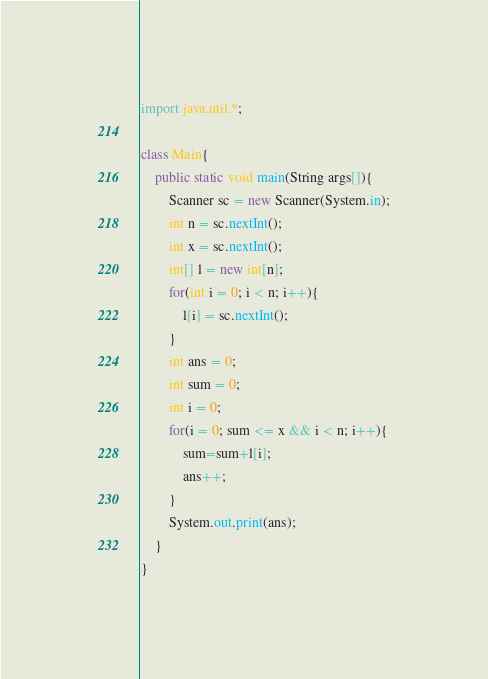Convert code to text. <code><loc_0><loc_0><loc_500><loc_500><_Java_>import java.util.*;

class Main{
	public static void main(String args[]){
		Scanner sc = new Scanner(System.in);
		int n = sc.nextInt();
		int x = sc.nextInt();
		int[] l = new int[n];
		for(int i = 0; i < n; i++){
			l[i] = sc.nextInt();
		}
		int ans = 0;
		int sum = 0;
		int i = 0;
		for(i = 0; sum <= x && i < n; i++){
			sum=sum+l[i];
			ans++;
		}
		System.out.print(ans);
	}
}
</code> 